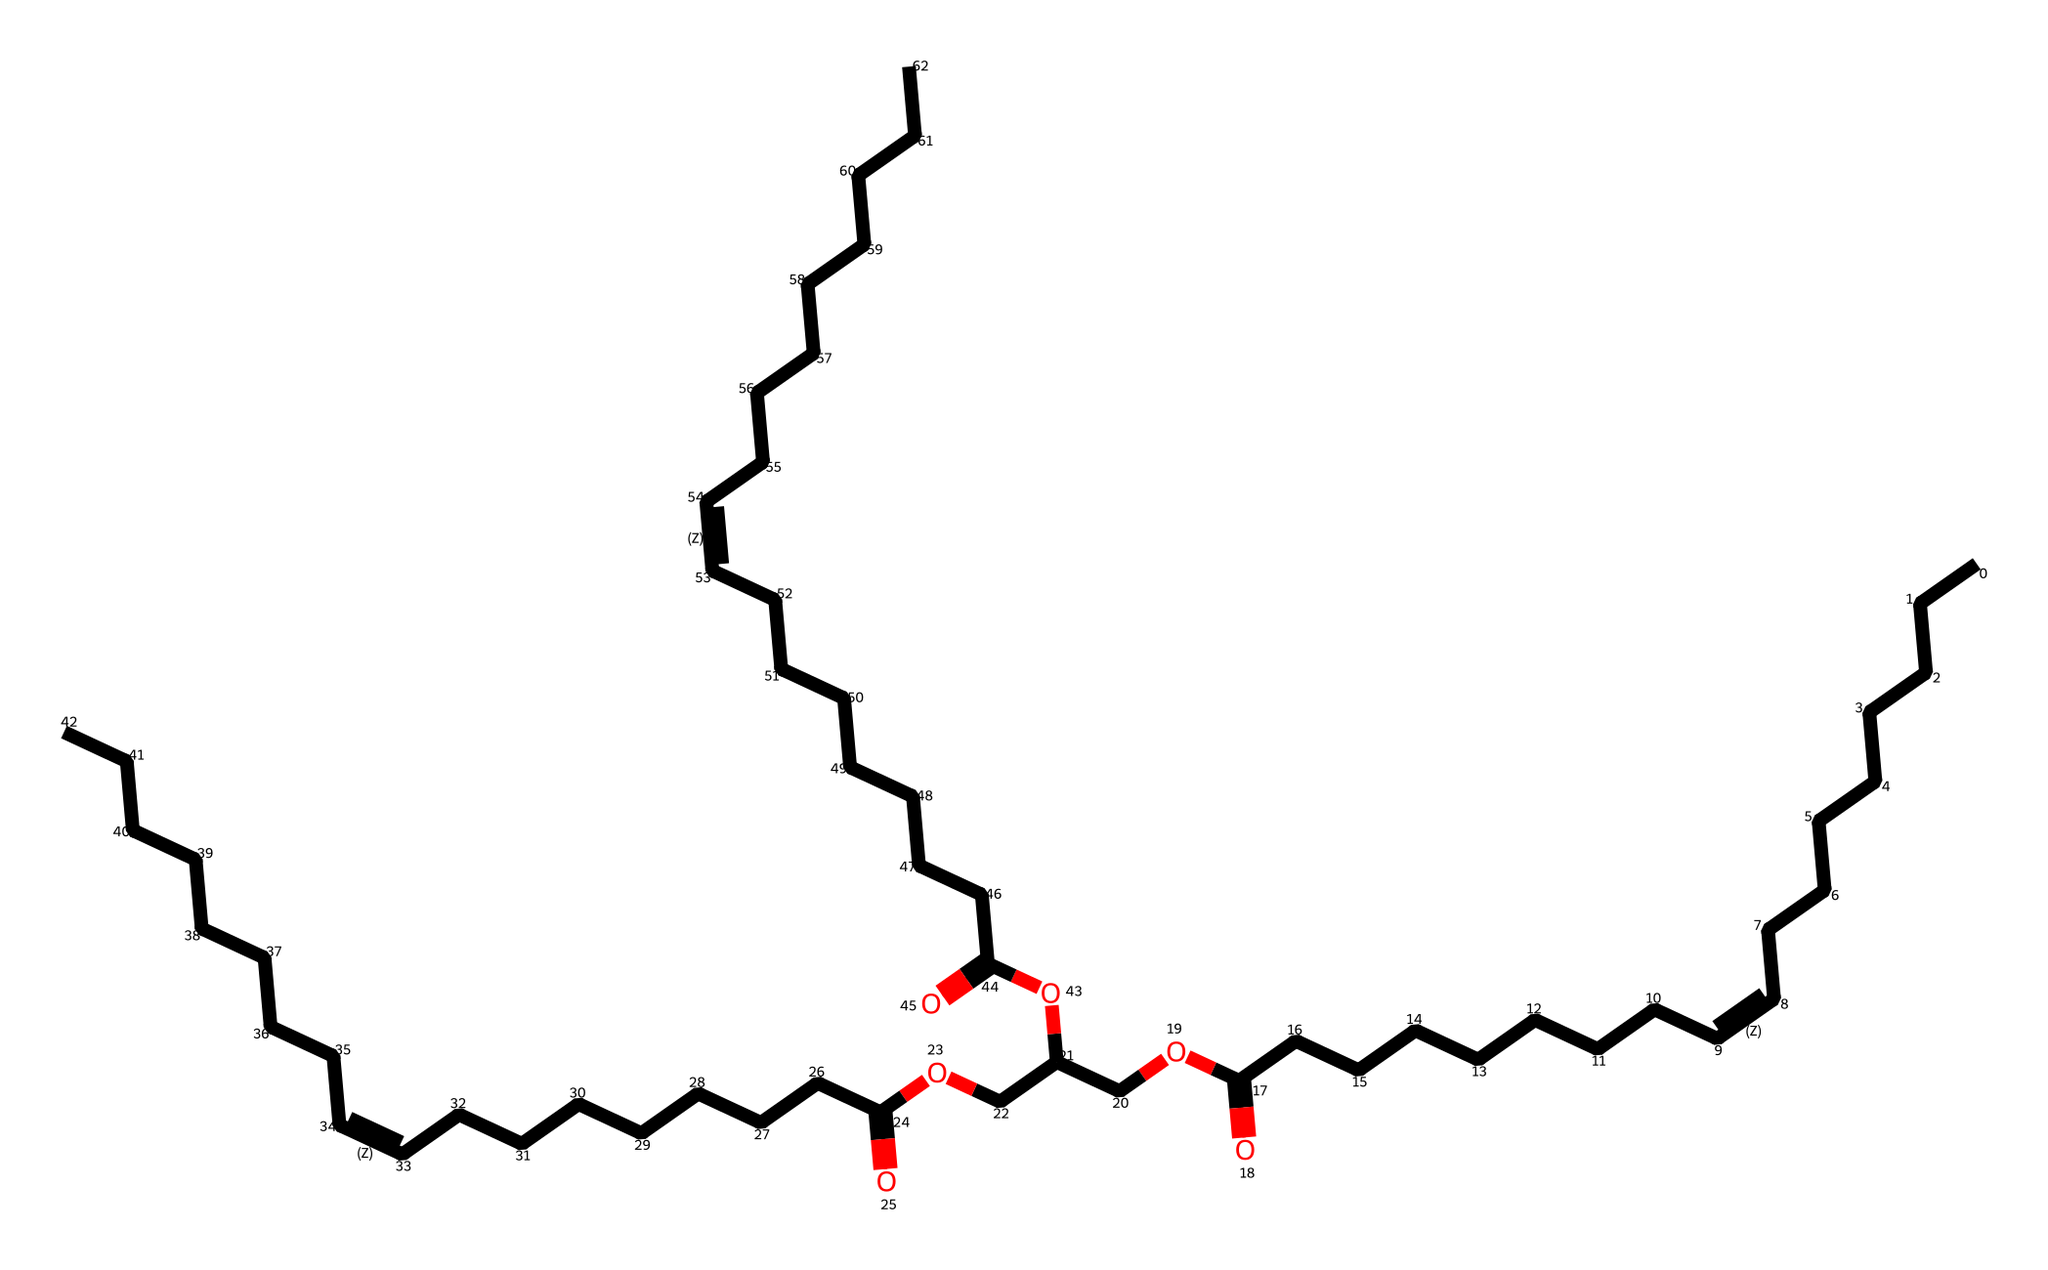What is the longest carbon chain length in this molecule? By examining the SMILES representation, we can identify the longest unbranched series of carbon atoms. The representation indicates a chain of carbon atoms without branching, which consists of 18 carbons in the longest segment.
Answer: 18 How many double bonds are present in this structure? In the SMILES string, the "/C=C\" notation signifies double bonds between particular carbon atoms. By counting these segments, we find there are three instances of double bonds in the molecule.
Answer: 3 What is the functional group indicated by "OCC"? The segment "OCC" denotes an ether linkage due to the presence of an oxygen atom connected to two carbon atoms. This functionality is characteristic of ethers within the structure.
Answer: ether What type of lubricant is olive oil classified as? Olive oil is classified as a semi-solid lubricant due to its viscous nature, which stems from its triglyceride composition. This classification is based on its physical properties and uses.
Answer: semi-solid How does the degree of unsaturation affect lubrication? The double bonds (indicated by the "/C=C\") lead to increased fluidity in the oil, enhancing its lubrication properties by reducing friction between surfaces. Unsaturation improves the lubricant's performance.
Answer: enhances fluidity What does the presence of acidic groups (like "O=C" and "-O") suggest about this compound? The "O=C" and "O" segments point to the presence of carboxylic acid functional groups, which contribute to the chemical's stability and functional properties as a lubricant. This indicates an ability to interact with surfaces effectively.
Answer: carboxylic acids 